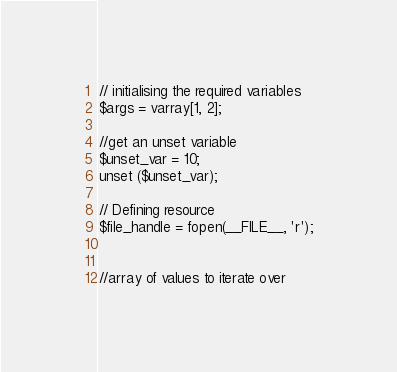<code> <loc_0><loc_0><loc_500><loc_500><_PHP_>
// initialising the required variables
$args = varray[1, 2];

//get an unset variable
$unset_var = 10;
unset ($unset_var);

// Defining resource
$file_handle = fopen(__FILE__, 'r');


//array of values to iterate over</code> 